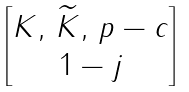<formula> <loc_0><loc_0><loc_500><loc_500>\begin{bmatrix} K , \, \widetilde { K } , \, p - c \\ 1 - j \end{bmatrix}</formula> 